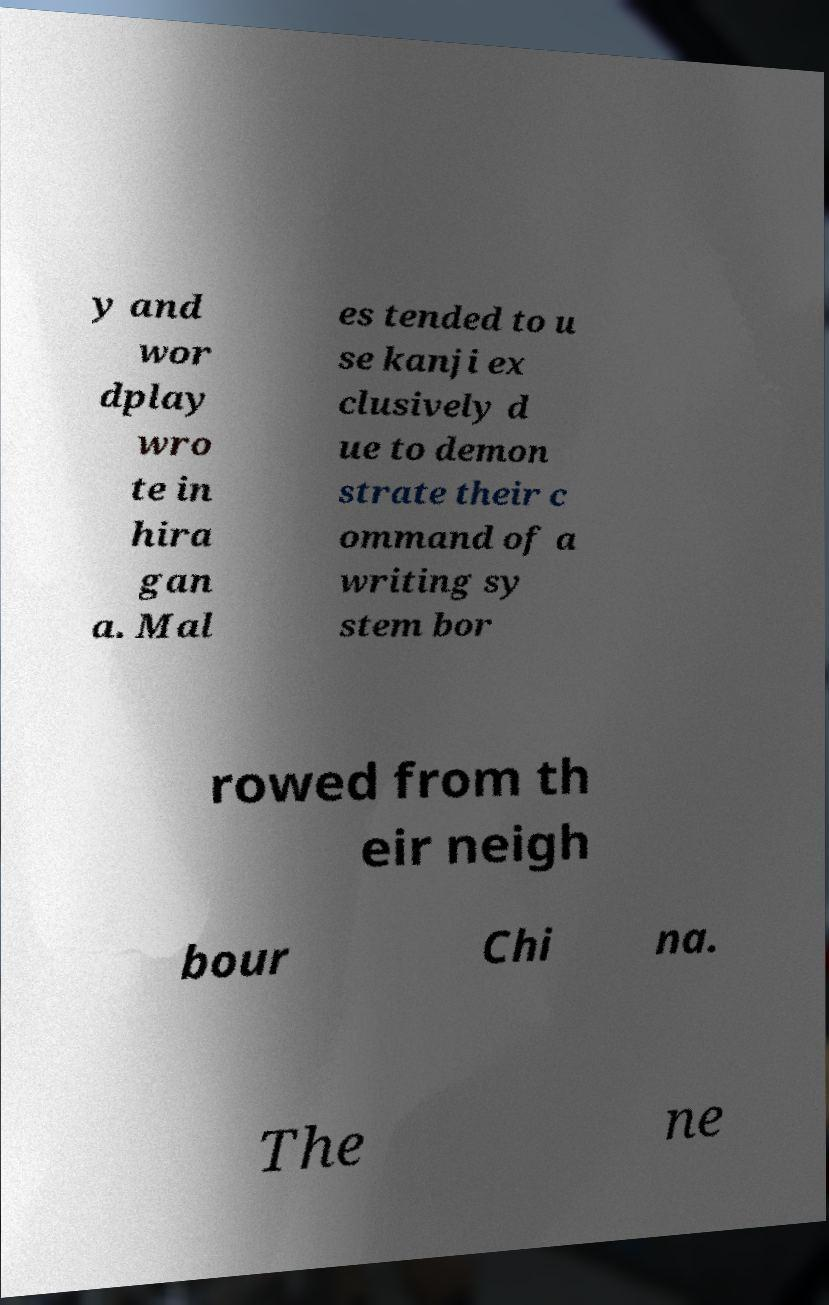What messages or text are displayed in this image? I need them in a readable, typed format. y and wor dplay wro te in hira gan a. Mal es tended to u se kanji ex clusively d ue to demon strate their c ommand of a writing sy stem bor rowed from th eir neigh bour Chi na. The ne 